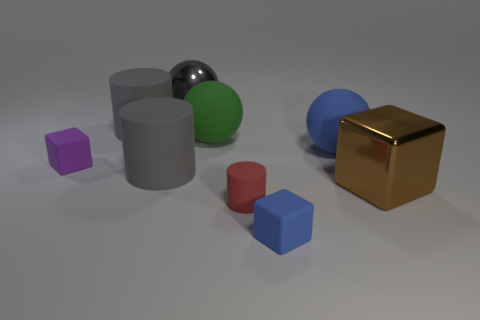Imagine if these objects were in a video game, what kind of game do you think it would be? Given the simplicity and geometric nature of these objects, they might be part of a puzzle or educational game designed to teach principles of physics, geometry, or spatial reasoning. Players could be challenged to sort, stack, or arrange these objects according to different criteria, such as color, size, or material properties. 